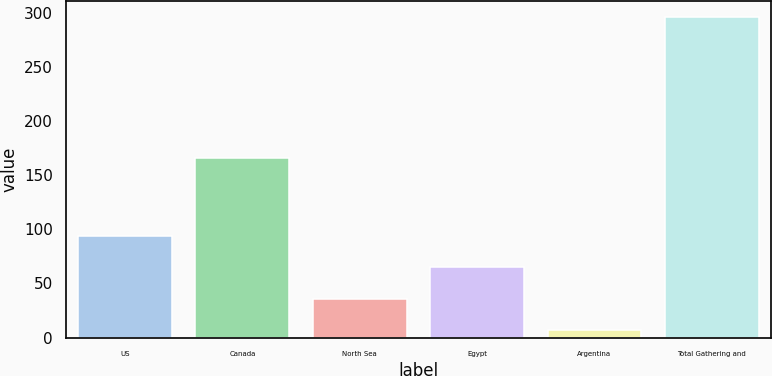Convert chart. <chart><loc_0><loc_0><loc_500><loc_500><bar_chart><fcel>US<fcel>Canada<fcel>North Sea<fcel>Egypt<fcel>Argentina<fcel>Total Gathering and<nl><fcel>93.7<fcel>166<fcel>35.9<fcel>64.8<fcel>7<fcel>296<nl></chart> 